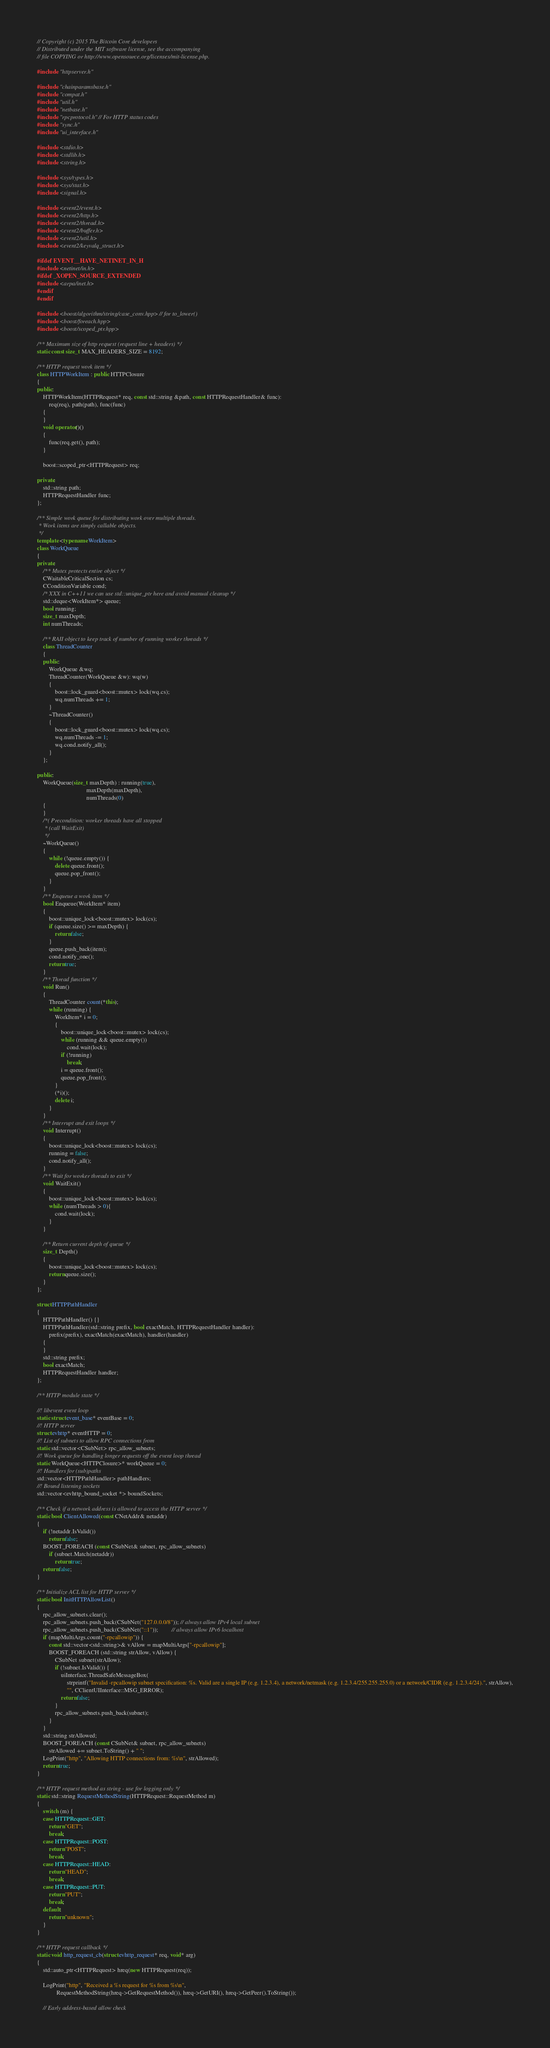<code> <loc_0><loc_0><loc_500><loc_500><_C++_>// Copyright (c) 2015 The Bitcoin Core developers
// Distributed under the MIT software license, see the accompanying
// file COPYING or http://www.opensource.org/licenses/mit-license.php.

#include "httpserver.h"

#include "chainparamsbase.h"
#include "compat.h"
#include "util.h"
#include "netbase.h"
#include "rpcprotocol.h" // For HTTP status codes
#include "sync.h"
#include "ui_interface.h"

#include <stdio.h>
#include <stdlib.h>
#include <string.h>

#include <sys/types.h>
#include <sys/stat.h>
#include <signal.h>

#include <event2/event.h>
#include <event2/http.h>
#include <event2/thread.h>
#include <event2/buffer.h>
#include <event2/util.h>
#include <event2/keyvalq_struct.h>

#ifdef EVENT__HAVE_NETINET_IN_H
#include <netinet/in.h>
#ifdef _XOPEN_SOURCE_EXTENDED
#include <arpa/inet.h>
#endif
#endif

#include <boost/algorithm/string/case_conv.hpp> // for to_lower()
#include <boost/foreach.hpp>
#include <boost/scoped_ptr.hpp>

/** Maximum size of http request (request line + headers) */
static const size_t MAX_HEADERS_SIZE = 8192;

/** HTTP request work item */
class HTTPWorkItem : public HTTPClosure
{
public:
    HTTPWorkItem(HTTPRequest* req, const std::string &path, const HTTPRequestHandler& func):
        req(req), path(path), func(func)
    {
    }
    void operator()()
    {
        func(req.get(), path);
    }

    boost::scoped_ptr<HTTPRequest> req;

private:
    std::string path;
    HTTPRequestHandler func;
};

/** Simple work queue for distributing work over multiple threads.
 * Work items are simply callable objects.
 */
template <typename WorkItem>
class WorkQueue
{
private:
    /** Mutex protects entire object */
    CWaitableCriticalSection cs;
    CConditionVariable cond;
    /* XXX in C++11 we can use std::unique_ptr here and avoid manual cleanup */
    std::deque<WorkItem*> queue;
    bool running;
    size_t maxDepth;
    int numThreads;

    /** RAII object to keep track of number of running worker threads */
    class ThreadCounter
    {
    public:
        WorkQueue &wq;
        ThreadCounter(WorkQueue &w): wq(w)
        {
            boost::lock_guard<boost::mutex> lock(wq.cs);
            wq.numThreads += 1;
        }
        ~ThreadCounter()
        {
            boost::lock_guard<boost::mutex> lock(wq.cs);
            wq.numThreads -= 1;
            wq.cond.notify_all();
        }
    };

public:
    WorkQueue(size_t maxDepth) : running(true),
                                 maxDepth(maxDepth),
                                 numThreads(0)
    {
    }
    /*( Precondition: worker threads have all stopped
     * (call WaitExit)
     */
    ~WorkQueue()
    {
        while (!queue.empty()) {
            delete queue.front();
            queue.pop_front();
        }
    }
    /** Enqueue a work item */
    bool Enqueue(WorkItem* item)
    {
        boost::unique_lock<boost::mutex> lock(cs);
        if (queue.size() >= maxDepth) {
            return false;
        }
        queue.push_back(item);
        cond.notify_one();
        return true;
    }
    /** Thread function */
    void Run()
    {
        ThreadCounter count(*this);
        while (running) {
            WorkItem* i = 0;
            {
                boost::unique_lock<boost::mutex> lock(cs);
                while (running && queue.empty())
                    cond.wait(lock);
                if (!running)
                    break;
                i = queue.front();
                queue.pop_front();
            }
            (*i)();
            delete i;
        }
    }
    /** Interrupt and exit loops */
    void Interrupt()
    {
        boost::unique_lock<boost::mutex> lock(cs);
        running = false;
        cond.notify_all();
    }
    /** Wait for worker threads to exit */
    void WaitExit()
    {
        boost::unique_lock<boost::mutex> lock(cs);
        while (numThreads > 0){
            cond.wait(lock);
        }
    }

    /** Return current depth of queue */
    size_t Depth()
    {
        boost::unique_lock<boost::mutex> lock(cs);
        return queue.size();
    }
};

struct HTTPPathHandler
{
    HTTPPathHandler() {}
    HTTPPathHandler(std::string prefix, bool exactMatch, HTTPRequestHandler handler):
        prefix(prefix), exactMatch(exactMatch), handler(handler)
    {
    }
    std::string prefix;
    bool exactMatch;
    HTTPRequestHandler handler;
};

/** HTTP module state */

//! libevent event loop
static struct event_base* eventBase = 0;
//! HTTP server
struct evhttp* eventHTTP = 0;
//! List of subnets to allow RPC connections from
static std::vector<CSubNet> rpc_allow_subnets;
//! Work queue for handling longer requests off the event loop thread
static WorkQueue<HTTPClosure>* workQueue = 0;
//! Handlers for (sub)paths
std::vector<HTTPPathHandler> pathHandlers;
//! Bound listening sockets
std::vector<evhttp_bound_socket *> boundSockets;

/** Check if a network address is allowed to access the HTTP server */
static bool ClientAllowed(const CNetAddr& netaddr)
{
    if (!netaddr.IsValid())
        return false;
    BOOST_FOREACH (const CSubNet& subnet, rpc_allow_subnets)
        if (subnet.Match(netaddr))
            return true;
    return false;
}

/** Initialize ACL list for HTTP server */
static bool InitHTTPAllowList()
{
    rpc_allow_subnets.clear();
    rpc_allow_subnets.push_back(CSubNet("127.0.0.0/8")); // always allow IPv4 local subnet
    rpc_allow_subnets.push_back(CSubNet("::1"));         // always allow IPv6 localhost
    if (mapMultiArgs.count("-rpcallowip")) {
        const std::vector<std::string>& vAllow = mapMultiArgs["-rpcallowip"];
        BOOST_FOREACH (std::string strAllow, vAllow) {
            CSubNet subnet(strAllow);
            if (!subnet.IsValid()) {
                uiInterface.ThreadSafeMessageBox(
                    strprintf("Invalid -rpcallowip subnet specification: %s. Valid are a single IP (e.g. 1.2.3.4), a network/netmask (e.g. 1.2.3.4/255.255.255.0) or a network/CIDR (e.g. 1.2.3.4/24).", strAllow),
                    "", CClientUIInterface::MSG_ERROR);
                return false;
            }
            rpc_allow_subnets.push_back(subnet);
        }
    }
    std::string strAllowed;
    BOOST_FOREACH (const CSubNet& subnet, rpc_allow_subnets)
        strAllowed += subnet.ToString() + " ";
    LogPrint("http", "Allowing HTTP connections from: %s\n", strAllowed);
    return true;
}

/** HTTP request method as string - use for logging only */
static std::string RequestMethodString(HTTPRequest::RequestMethod m)
{
    switch (m) {
    case HTTPRequest::GET:
        return "GET";
        break;
    case HTTPRequest::POST:
        return "POST";
        break;
    case HTTPRequest::HEAD:
        return "HEAD";
        break;
    case HTTPRequest::PUT:
        return "PUT";
        break;
    default:
        return "unknown";
    }
}

/** HTTP request callback */
static void http_request_cb(struct evhttp_request* req, void* arg)
{
    std::auto_ptr<HTTPRequest> hreq(new HTTPRequest(req));

    LogPrint("http", "Received a %s request for %s from %s\n",
             RequestMethodString(hreq->GetRequestMethod()), hreq->GetURI(), hreq->GetPeer().ToString());

    // Early address-based allow check</code> 